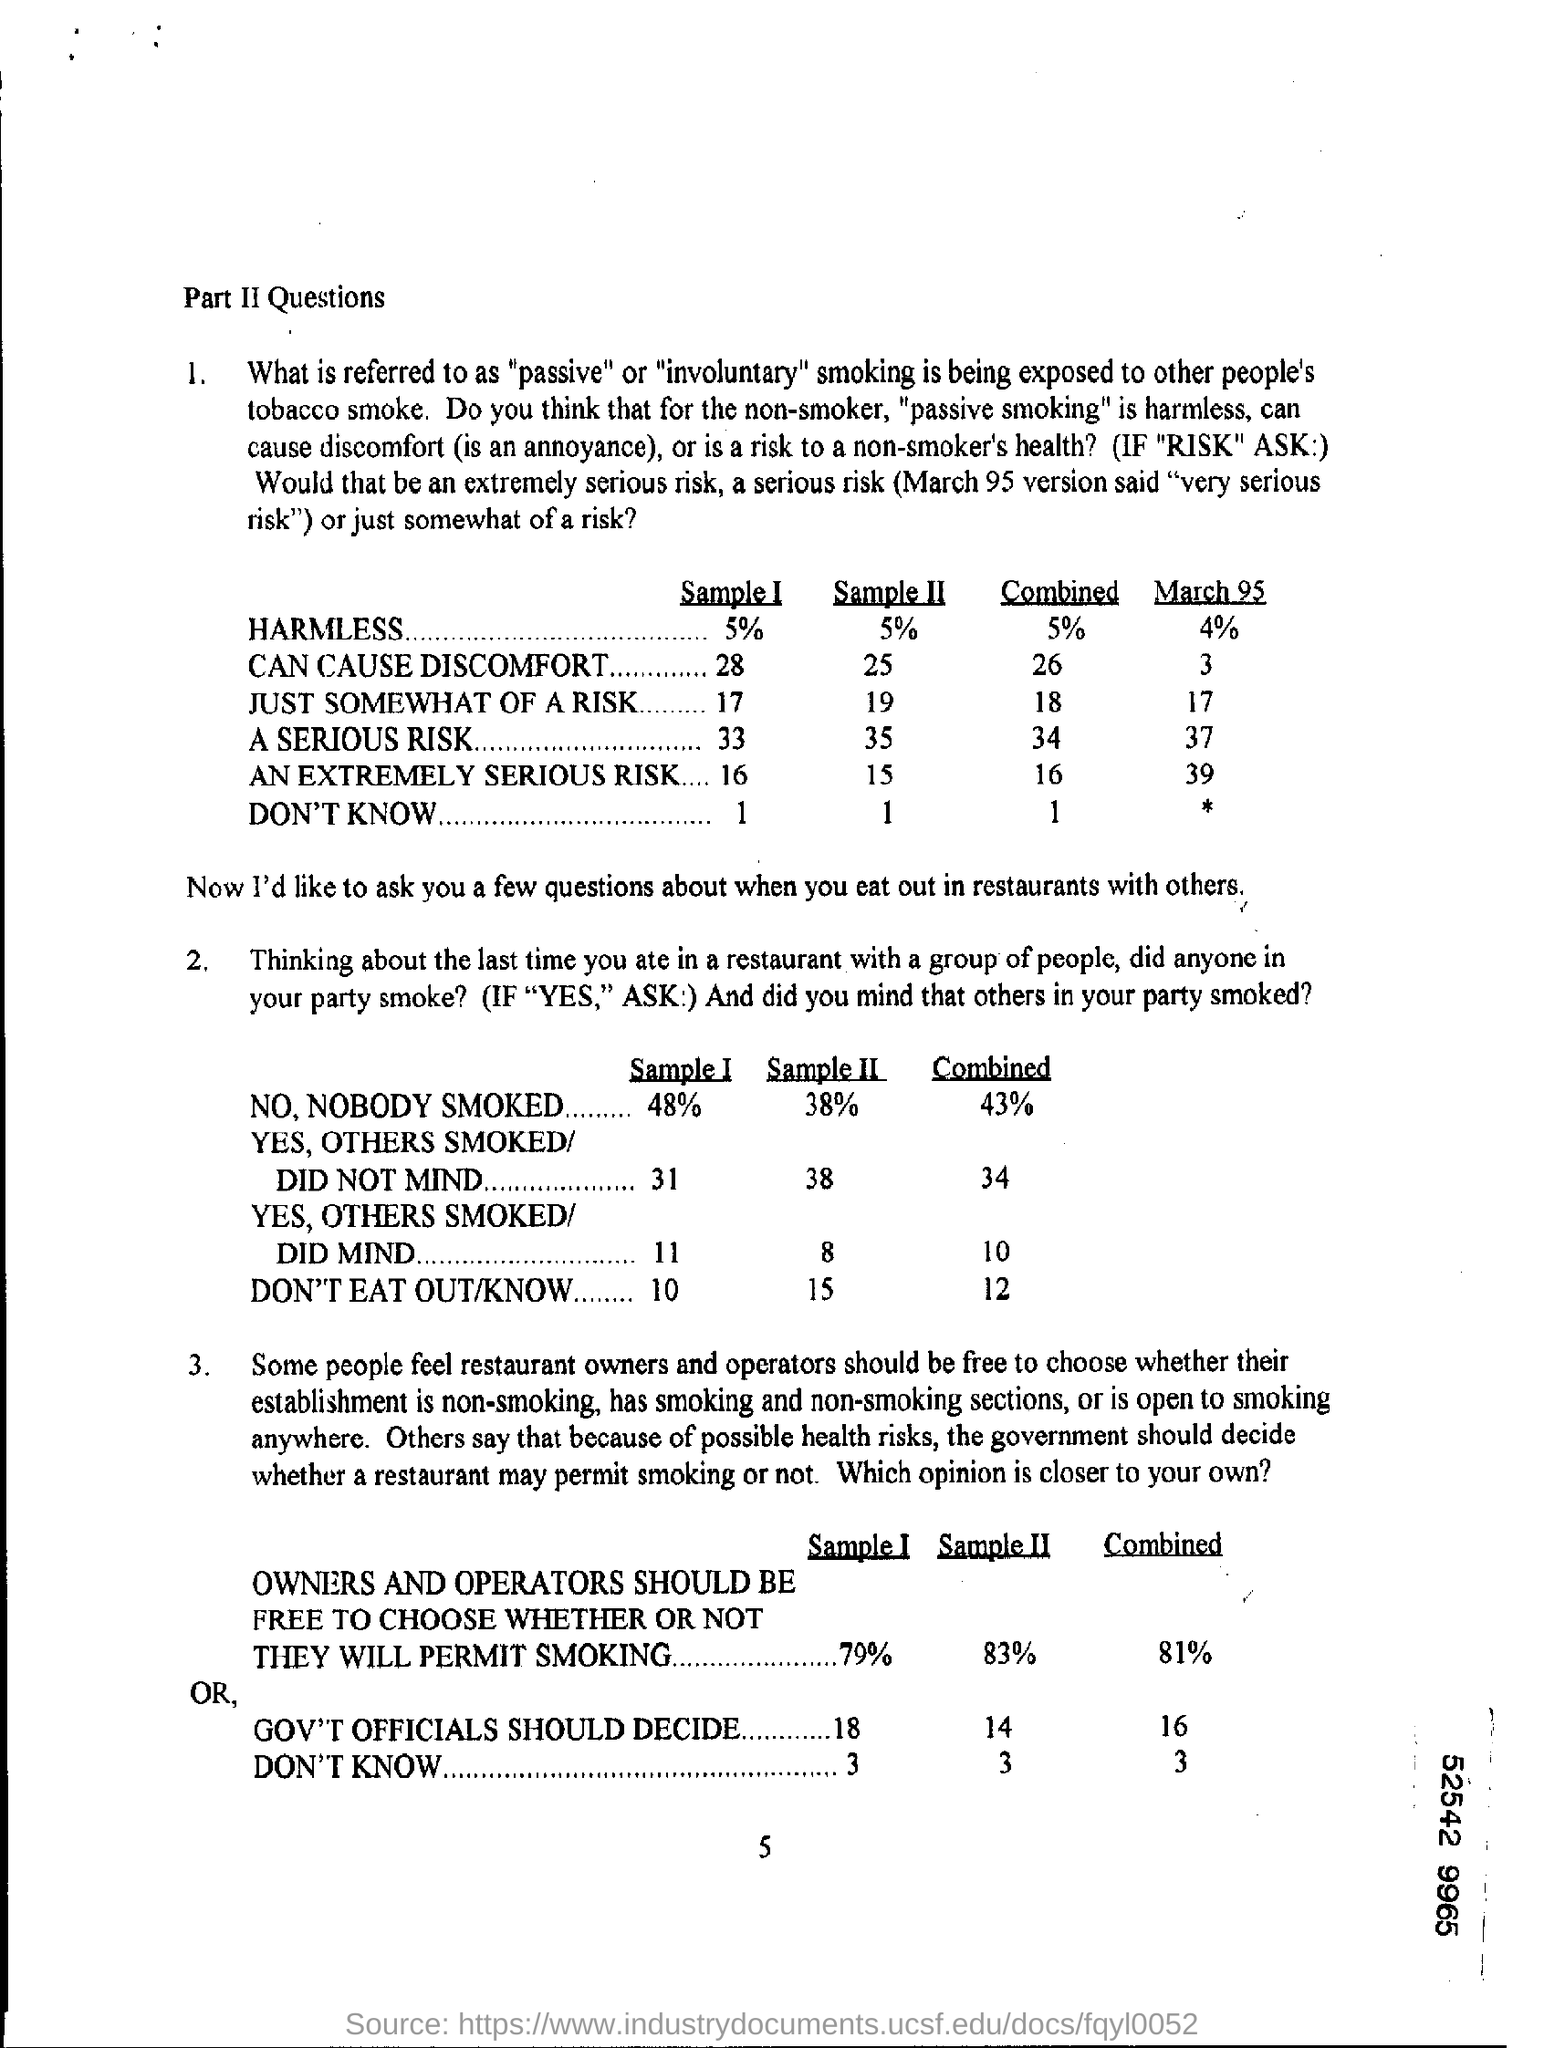Point out several critical features in this image. The number at the bottom of the page is 5. The percentage of harmless substances in sample I is 5%. 